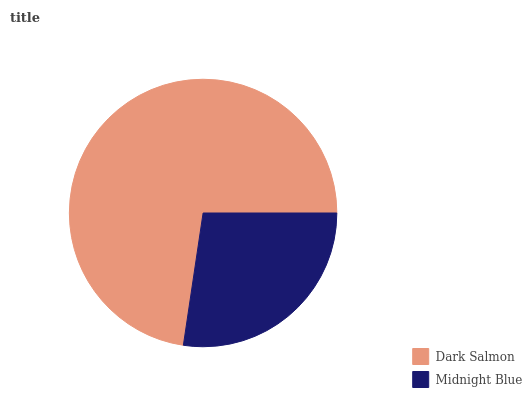Is Midnight Blue the minimum?
Answer yes or no. Yes. Is Dark Salmon the maximum?
Answer yes or no. Yes. Is Midnight Blue the maximum?
Answer yes or no. No. Is Dark Salmon greater than Midnight Blue?
Answer yes or no. Yes. Is Midnight Blue less than Dark Salmon?
Answer yes or no. Yes. Is Midnight Blue greater than Dark Salmon?
Answer yes or no. No. Is Dark Salmon less than Midnight Blue?
Answer yes or no. No. Is Dark Salmon the high median?
Answer yes or no. Yes. Is Midnight Blue the low median?
Answer yes or no. Yes. Is Midnight Blue the high median?
Answer yes or no. No. Is Dark Salmon the low median?
Answer yes or no. No. 